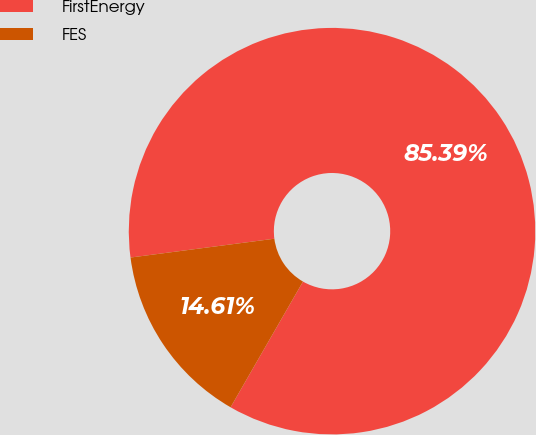Convert chart to OTSL. <chart><loc_0><loc_0><loc_500><loc_500><pie_chart><fcel>FirstEnergy<fcel>FES<nl><fcel>85.39%<fcel>14.61%<nl></chart> 